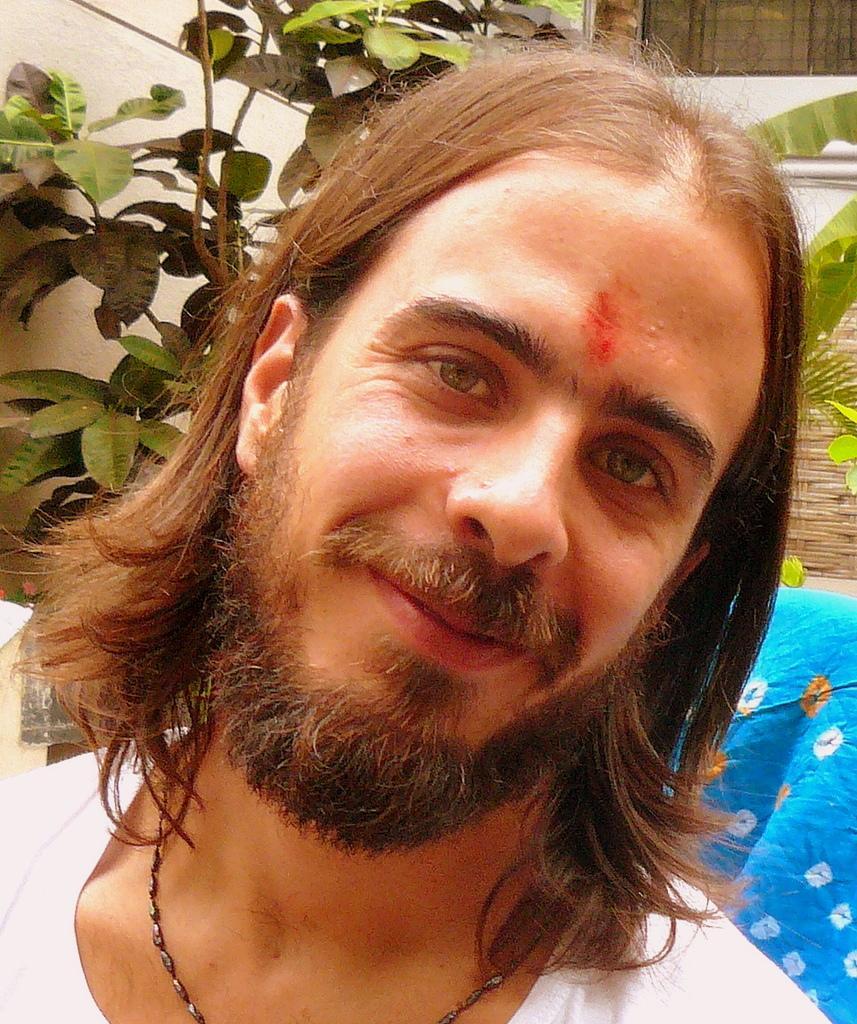Describe this image in one or two sentences. In this image ,in the foreground there is a man having short hair and behind the man there are many leaves of a plant. 